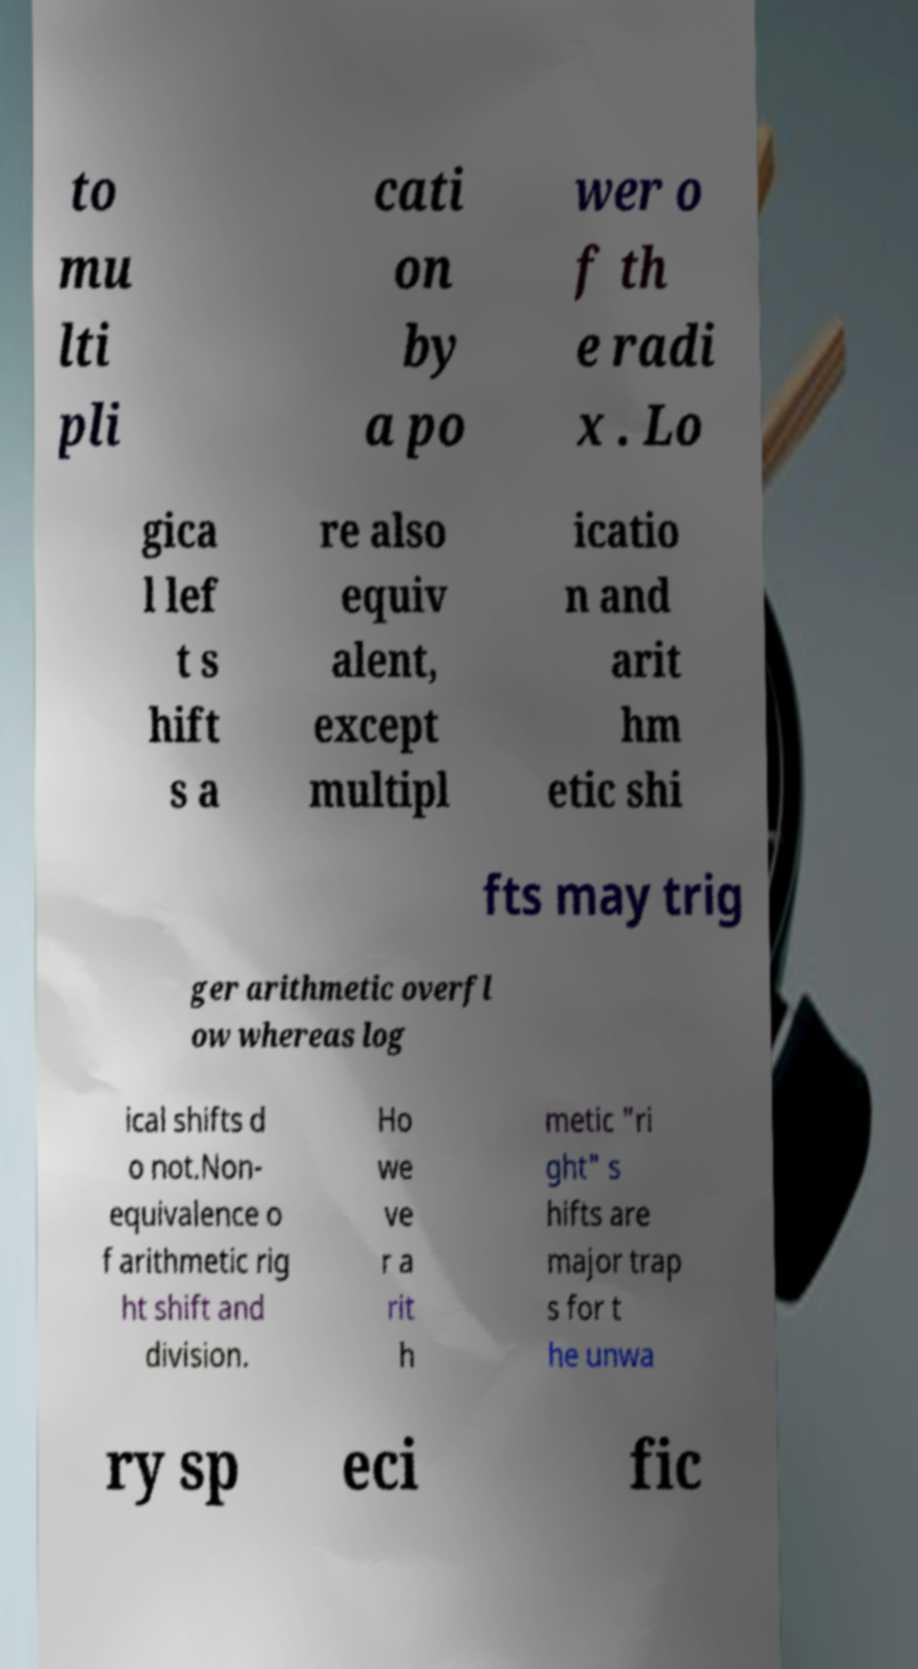Can you accurately transcribe the text from the provided image for me? to mu lti pli cati on by a po wer o f th e radi x . Lo gica l lef t s hift s a re also equiv alent, except multipl icatio n and arit hm etic shi fts may trig ger arithmetic overfl ow whereas log ical shifts d o not.Non- equivalence o f arithmetic rig ht shift and division. Ho we ve r a rit h metic "ri ght" s hifts are major trap s for t he unwa ry sp eci fic 